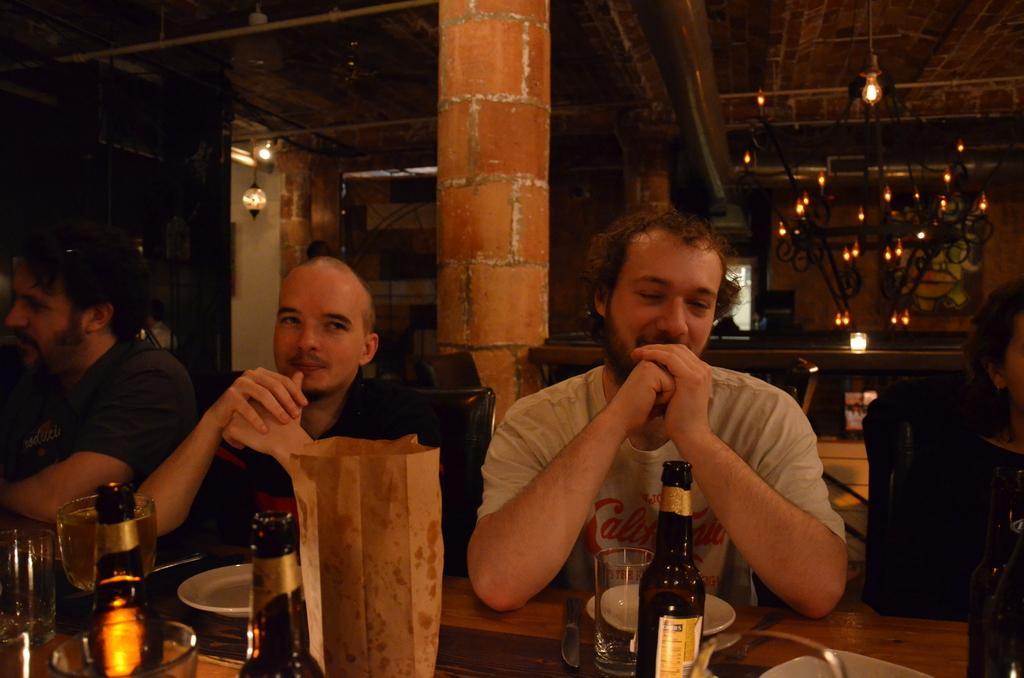Describe this image in one or two sentences. In this image there are group of people sitting around the table in the chairs. On the table there are glass bottles,glasses,packets,plates,knives on it. In the background there is a pillar. At the top there is ceiling with the lights. In the background there are lights. 